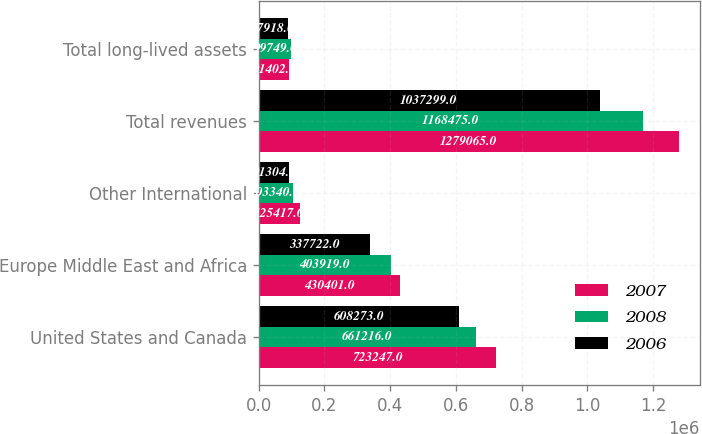Convert chart to OTSL. <chart><loc_0><loc_0><loc_500><loc_500><stacked_bar_chart><ecel><fcel>United States and Canada<fcel>Europe Middle East and Africa<fcel>Other International<fcel>Total revenues<fcel>Total long-lived assets<nl><fcel>2007<fcel>723247<fcel>430401<fcel>125417<fcel>1.27906e+06<fcel>91402<nl><fcel>2008<fcel>661216<fcel>403919<fcel>103340<fcel>1.16848e+06<fcel>99749<nl><fcel>2006<fcel>608273<fcel>337722<fcel>91304<fcel>1.0373e+06<fcel>87918<nl></chart> 